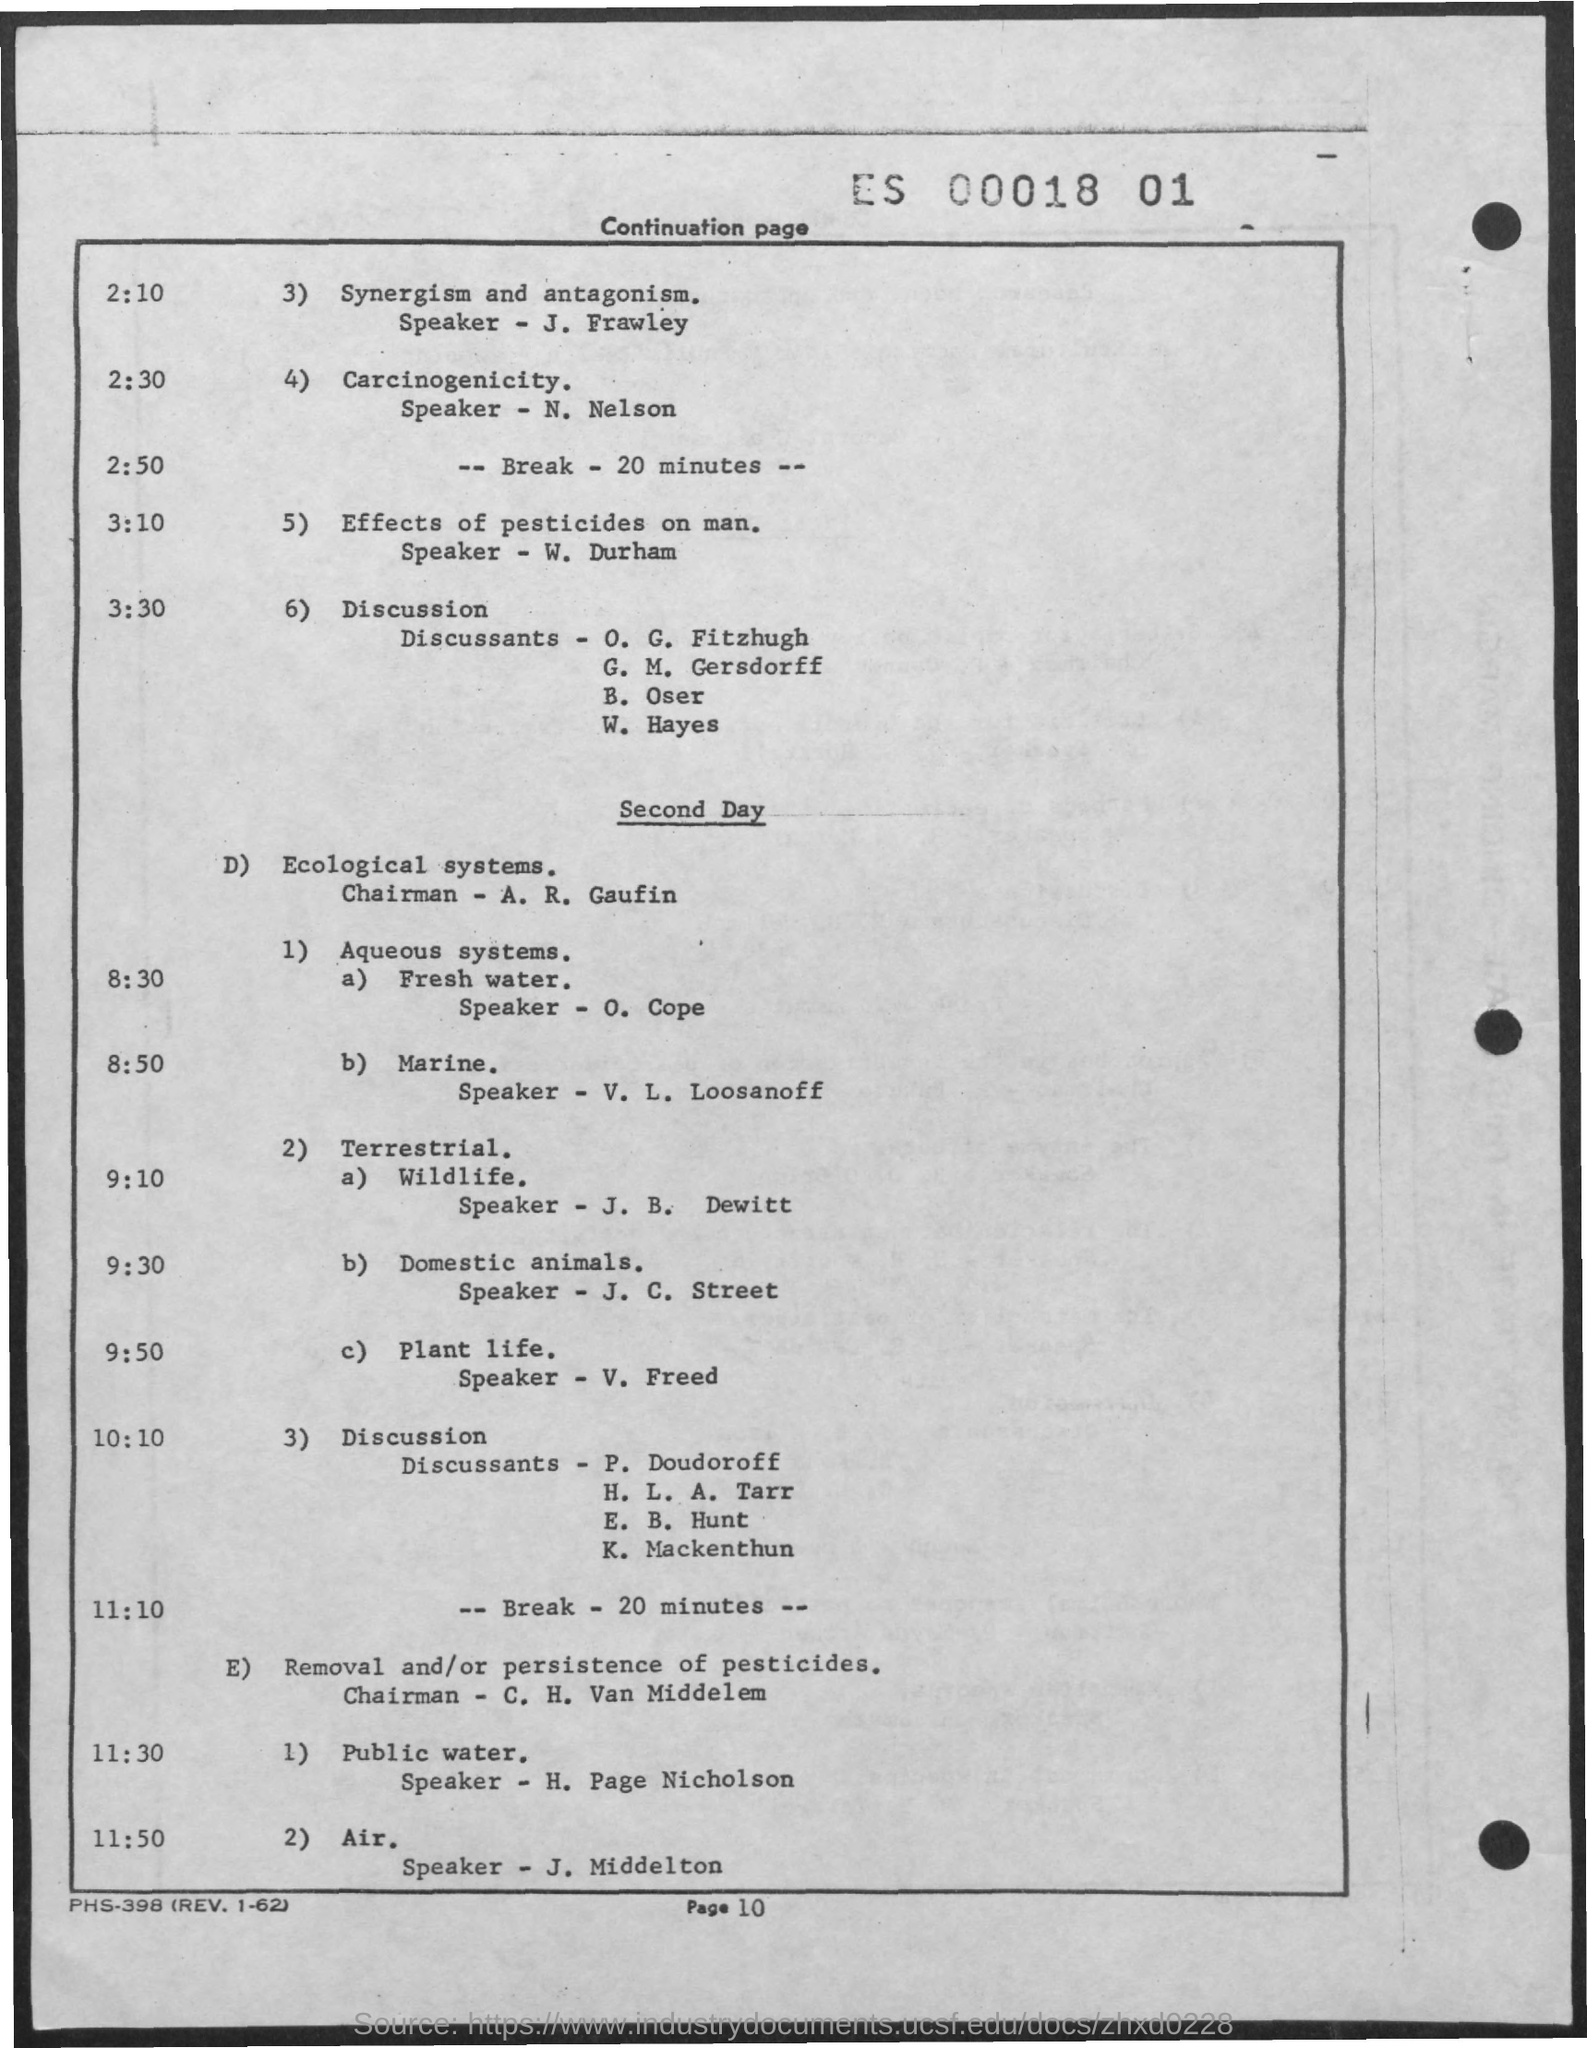Identify some key points in this picture. On the second day, O. Cope is the speaker discussing fresh water. The speaker on Wildlife is J.B. Dewitt. The speaker of the article on Domestic Animals is J. C. Street. The speaker on Public Water is H. Page Nicholson. J. Frawley is the speaker on the topics of Synergism and Antagonism. 